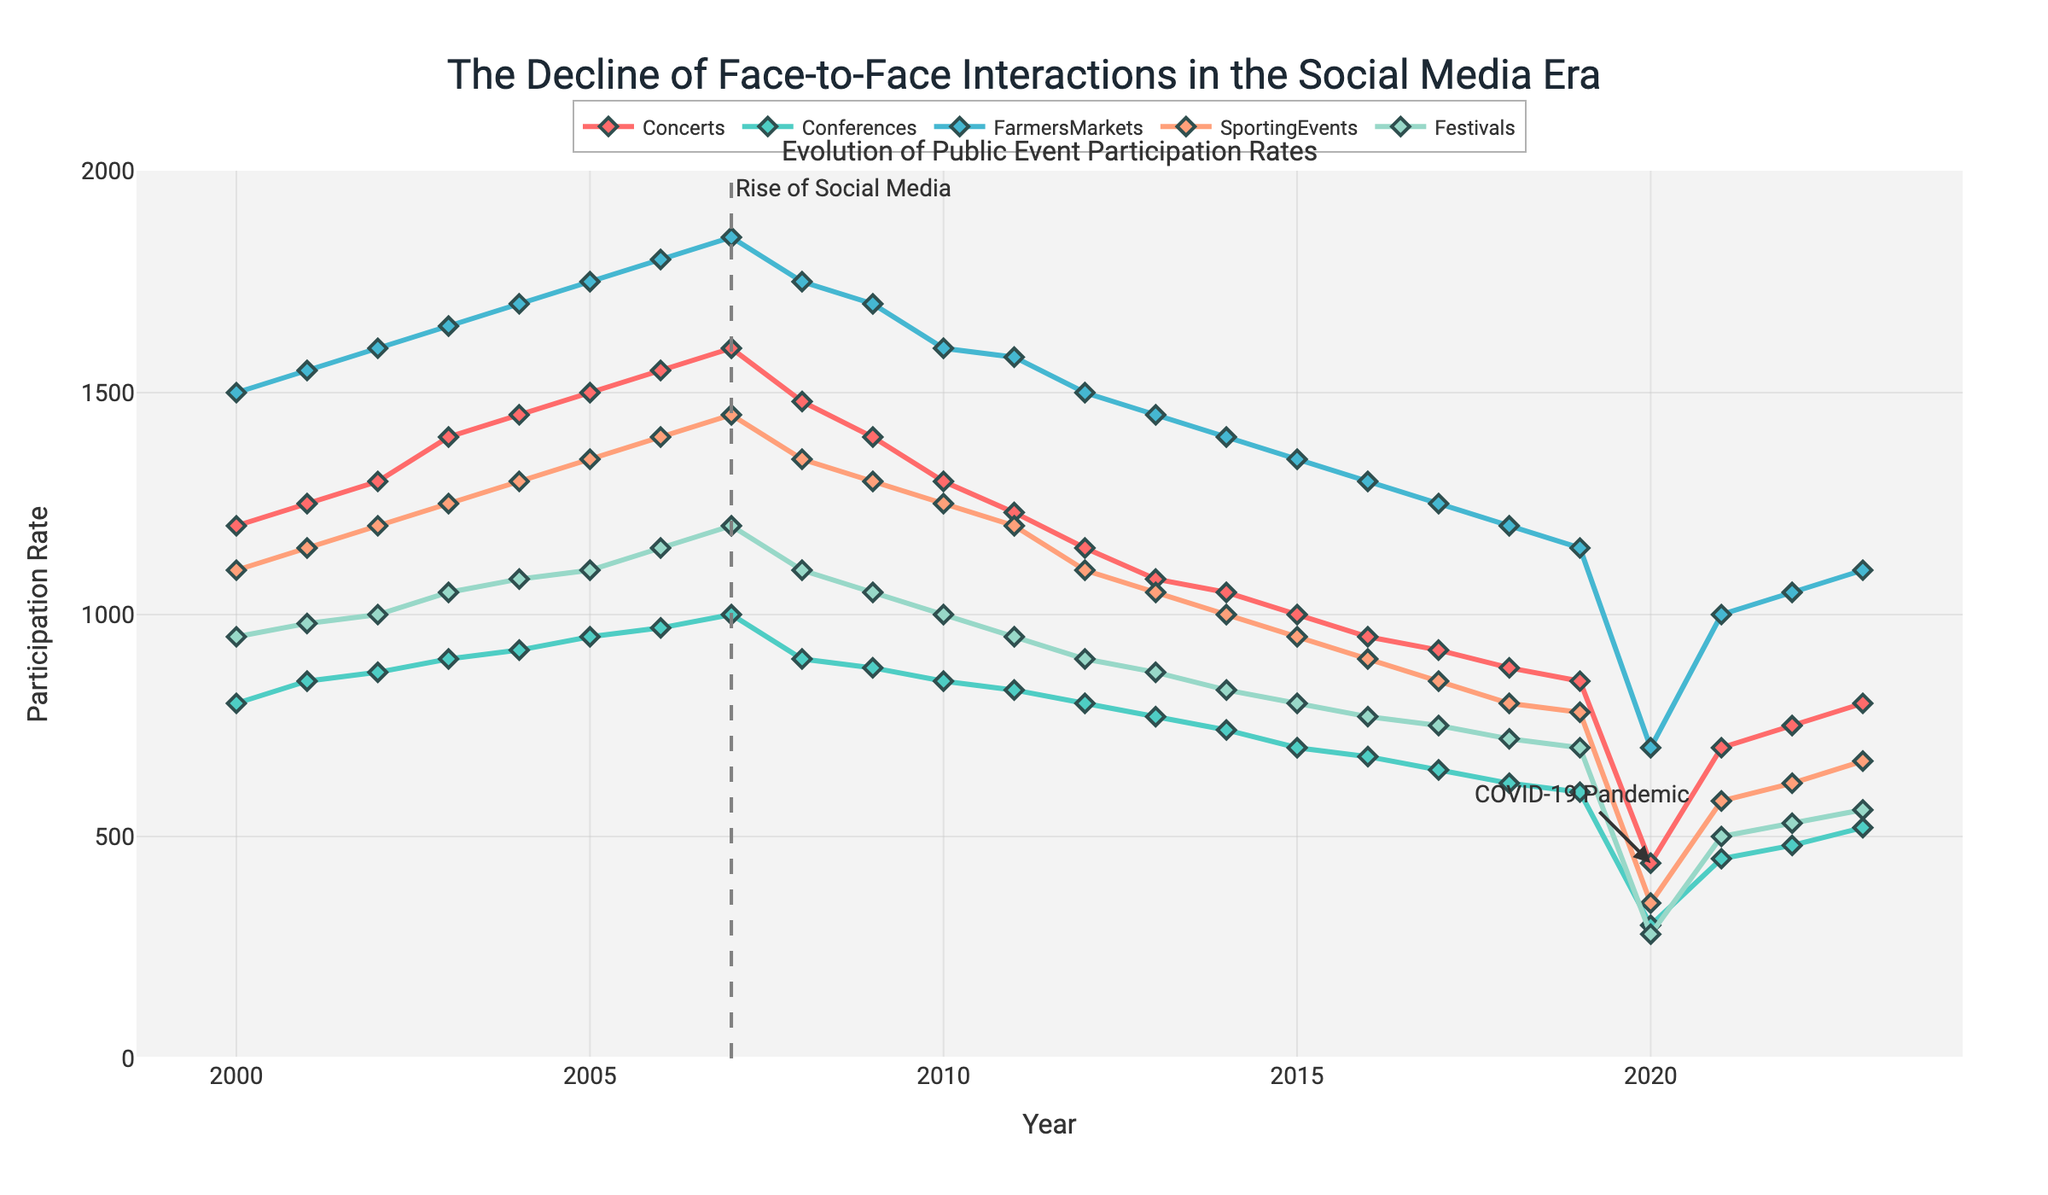When did the "Rise of Social Media" occur according to the figure? The "Rise of Social Media" is annotated with a vertical line on the figure, which occurs around 2007.
Answer: 2007 Which event had the highest participation rate in 2005? By observing the data points in 2005, Farmers Markets show the highest participation rate compared to Concerts, Conferences, Sporting Events, and Festivals.
Answer: Farmers Markets What general trend can be observed for all event participation rates post-2007 until 2019? Post-2007, there is a noticeable decline in participation rates across all event types until 2019, excluding fluctuations.
Answer: Decline How did the participation rate for Concerts change from 2019 to 2020? The participation rate for Concerts in 2019 was 850 and it dropped to 440 in 2020. This indicates a significant decrease, likely due to the COVID-19 pandemic.
Answer: Decreased Which event saw the smallest impact by the COVID-19 pandemic in 2020? Looking at the data points for 2020, Farmers Markets had a participation rate of 700, which, though reduced, is still higher compared to other events such as Concerts, Conferences, Sporting Events, and Festivals.
Answer: Farmers Markets By how much did the participation rate for Sporting Events change between 2006 and 2016? Participation for Sporting Events in 2006 was 1400 and in 2016 it was 900. The change is calculated by the difference 1400 - 900 = 500.
Answer: 500 Between which years did Conferences see their peak participation rate? According to the figure, the highest participation rate for Conferences occurs around 2007 with a rate close to 1000.
Answer: Around 2007 What was the participation rate recovery trend for Festivals after the COVID-19 pandemic? After the significant drop in 2020, the participation rate for Festivals rose gradually from 280 in 2020 to 530 in 2022.
Answer: Gradual recovery Which event type had the least variation in participation rate from 2000 to 2019? By observing the data trends, Farmers Markets showed a relatively stable participation rate with less dramatic fluctuations compared to other event types.
Answer: Farmers Markets 